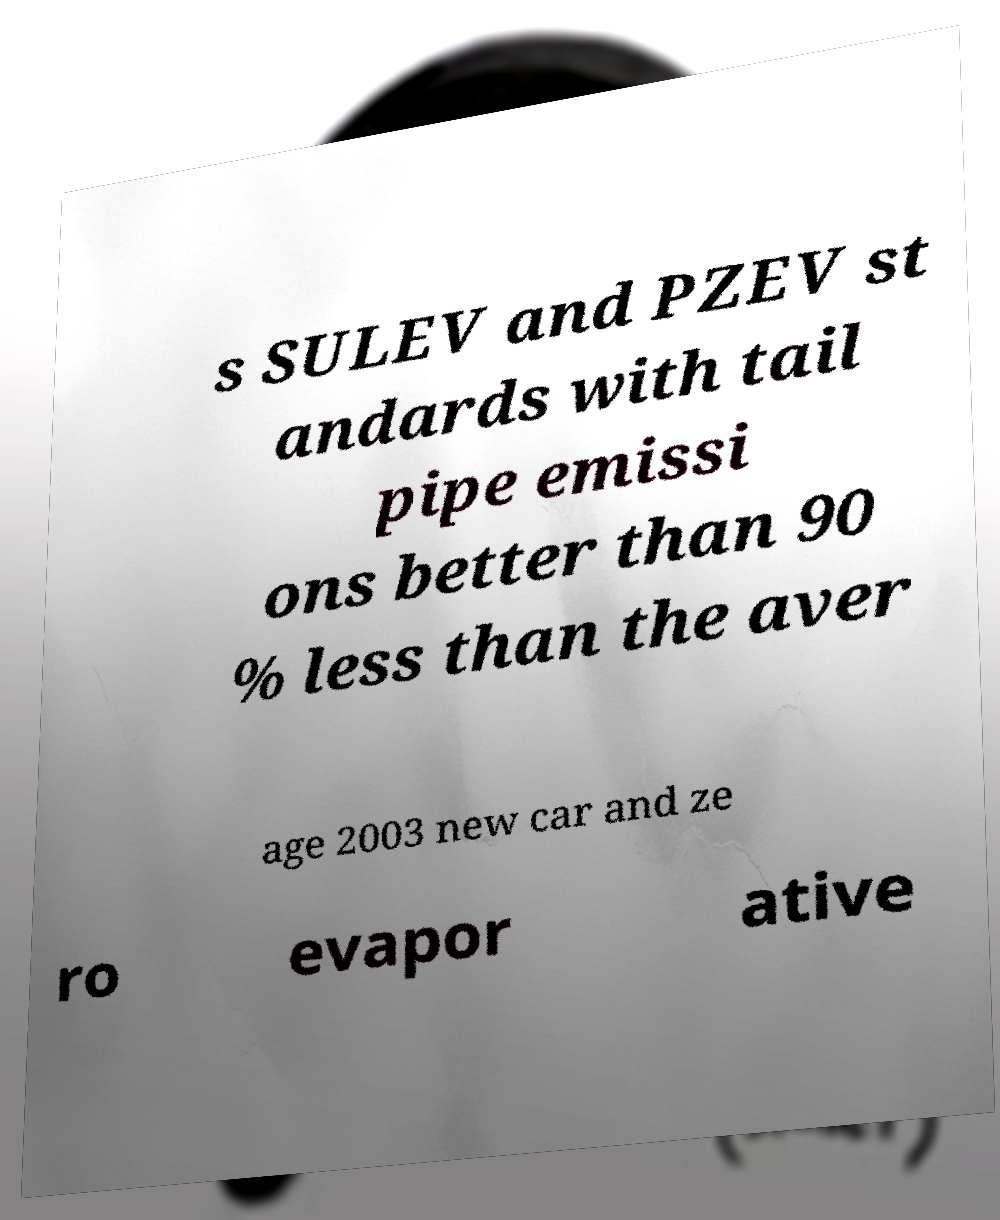Please identify and transcribe the text found in this image. s SULEV and PZEV st andards with tail pipe emissi ons better than 90 % less than the aver age 2003 new car and ze ro evapor ative 